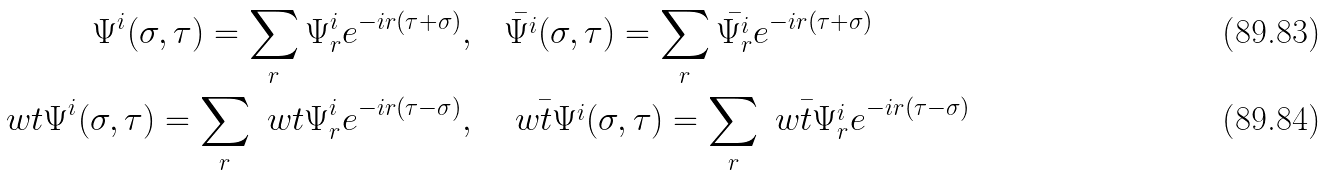<formula> <loc_0><loc_0><loc_500><loc_500>\Psi ^ { i } ( \sigma , \tau ) = \sum _ { r } \Psi ^ { i } _ { r } e ^ { - i r ( \tau + \sigma ) } , & \quad \bar { \Psi ^ { i } } ( \sigma , \tau ) = \sum _ { r } \bar { \Psi ^ { i } _ { r } } e ^ { - i r ( \tau + \sigma ) } \\ \ w t { \Psi } ^ { i } ( \sigma , \tau ) = \sum _ { r } \ w t { \Psi } ^ { i } _ { r } e ^ { - i r ( \tau - \sigma ) } , & \quad \bar { \ w t { \Psi } ^ { i } } ( \sigma , \tau ) = \sum _ { r } \bar { \ w t { \Psi } ^ { i } _ { r } } e ^ { - i r ( \tau - \sigma ) }</formula> 